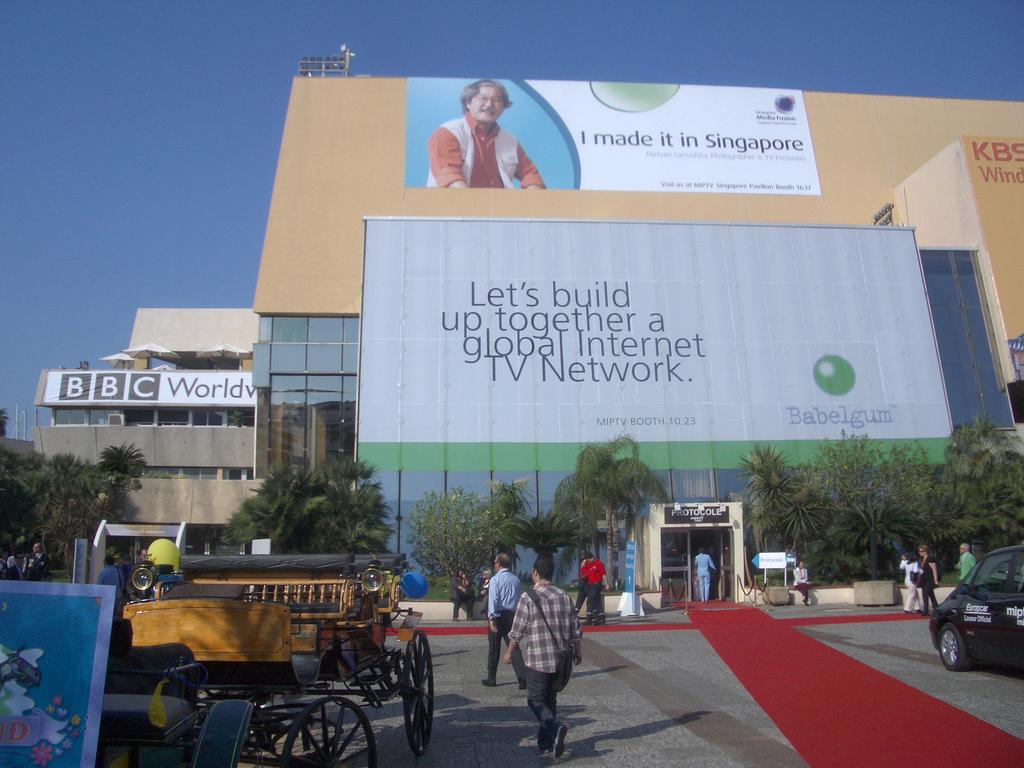<image>
Offer a succinct explanation of the picture presented. The ad on the left side is for BBC World News 